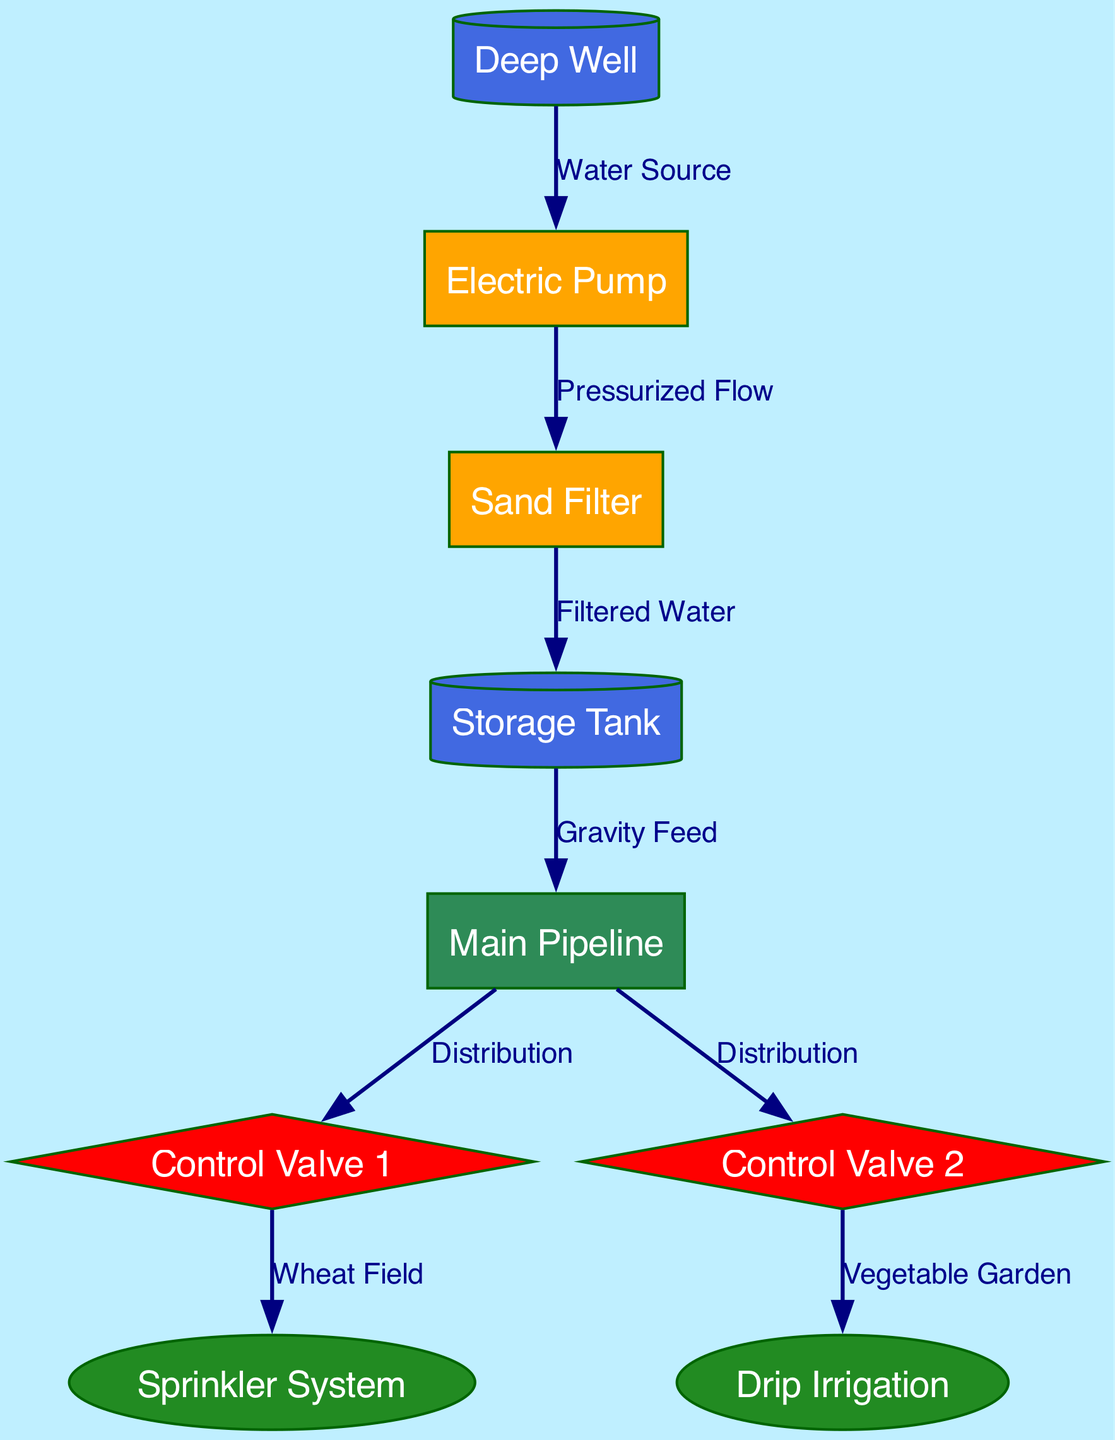What is the primary water source for the irrigation system? The diagram shows that the water source is a Deep Well, which is directly connected to the Electric Pump.
Answer: Deep Well How many control valves are in the irrigation system? Upon examining the diagram, there are two control valves indicated, labeled as Control Valve 1 and Control Valve 2.
Answer: 2 What type of irrigation system is used for the vegetable garden? The diagram illustrates a connection from Control Valve 2 to Drip Irrigation, indicating that drip irrigation is utilized for the vegetable garden.
Answer: Drip Irrigation What is the function of the storage tank in this irrigation system? The storage tank receives filtered water from the Sand Filter and provides a gravity feed to the Main Pipeline, serving as a reservoir before distribution.
Answer: Storage Which node connects to the sprinklers? Tracing the path from Control Valve 1, the diagram shows that it connects to the Sprinkler System, indicating that this component irrigates the wheat field.
Answer: Sprinkler System What is the relationship between the pump and the filter? The water flows from the Electric Pump to the Sand Filter as a pressurized flow, demonstrating the direct process of moving water to be filtered for irrigation.
Answer: Pressurized Flow From which node does water first enter the irrigation system? The diagram indicates that water first enters through the Deep Well, serving as the initial point before pumping and filtering.
Answer: Deep Well What method of water distribution is used for the wheat field? The diagram shows that Control Valve 1 is connected to the Sprinkler System, revealing that sprinklers are used for distributing water to the wheat field.
Answer: Sprinkler System 